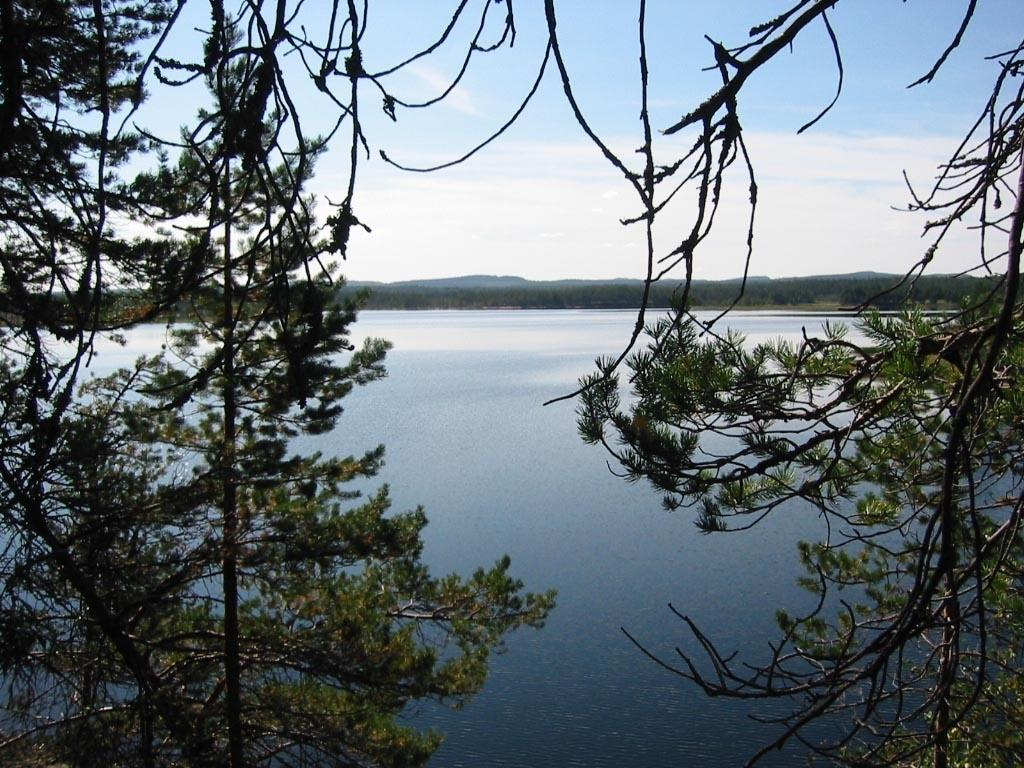What type of living organisms can be seen in the image? Plants and trees are visible in the image. What is the color of the plants and trees in the image? The plants and trees are in green color. Can you describe the background of the image? There is water visible in the background of the image. What is the color of the sky in the image? The sky is blue and white in color. Where is the key hidden in the image? There is no key present in the image. What type of rock can be seen in the image? There is no rock visible in the image. 